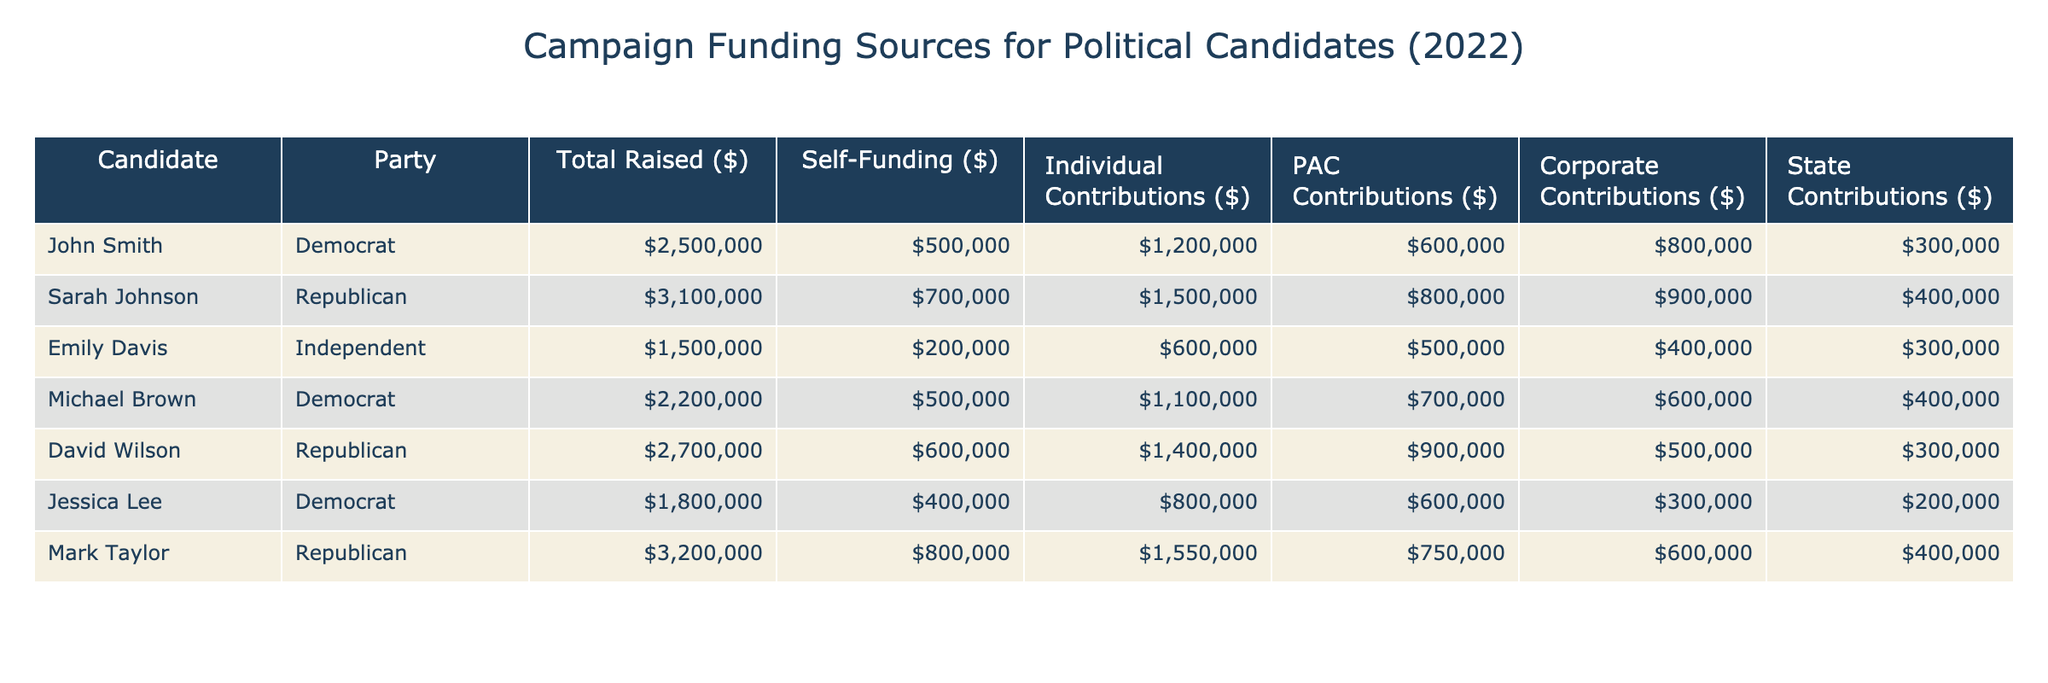What is the total amount raised by Sarah Johnson? To find the total amount raised by Sarah Johnson, refer to her row in the table. The value under the "Total Raised ($)" column is 3,100,000.
Answer: 3,100,000 Which candidate received more PAC contributions, John Smith or David Wilson? Compare the values in the "PAC Contributions ($)" column for both candidates. John Smith received 600,000, while David Wilson received 900,000. Since 900,000 is greater than 600,000, David Wilson received more PAC contributions.
Answer: David Wilson What is the total amount of individual contributions for all Democratic candidates combined? First, identify the Democratic candidates: John Smith, Michael Brown, and Jessica Lee. Their individual contributions are 1,200,000, 1,100,000, and 800,000 respectively. Add these amounts: 1,200,000 + 1,100,000 + 800,000 = 3,100,000.
Answer: 3,100,000 Did Mark Taylor self-fund more than Emily Davis? Check the "Self-Funding ($)" column for both candidates. Mark Taylor self-funded 800,000 while Emily Davis self-funded 200,000. Since 800,000 is greater than 200,000, Mark Taylor did self-fund more.
Answer: Yes What percentage of total raised funds for Jessica Lee came from Corporate Contributions? Jessica Lee's total raised funds are 1,800,000 and Corporate Contributions are 300,000. To find the percentage, use the formula: (Corporate Contributions / Total Raised) * 100. Thus, (300,000 / 1,800,000) * 100 = 16.67%.
Answer: 16.67% Which party raised more money in total, Republican or Democrat? Sum the total raised amounts from each party. Republicans (Sarah Johnson, David Wilson, Mark Taylor) raised 3,100,000 + 2,700,000 + 3,200,000 = 9,000,000. Democrats (John Smith, Michael Brown, Jessica Lee) raised 2,500,000 + 2,200,000 + 1,800,000 = 6,500,000. Since 9,000,000 is greater than 6,500,000, Republicans raised more.
Answer: Republicans Is the total raised amount from all candidates greater than 10 million dollars? Add the total raised amounts for all candidates: 2,500,000 + 3,100,000 + 1,500,000 + 2,200,000 + 2,700,000 + 1,800,000 + 3,200,000 = 17,000,000. Since 17,000,000 is greater than 10,000,000, the statement is true.
Answer: Yes Which candidate raised the least amount of funds? Review the "Total Raised ($)" column for all candidates. Emily Davis has the lowest total raised at 1,500,000. Thus, she is the candidate who raised the least amount.
Answer: Emily Davis 